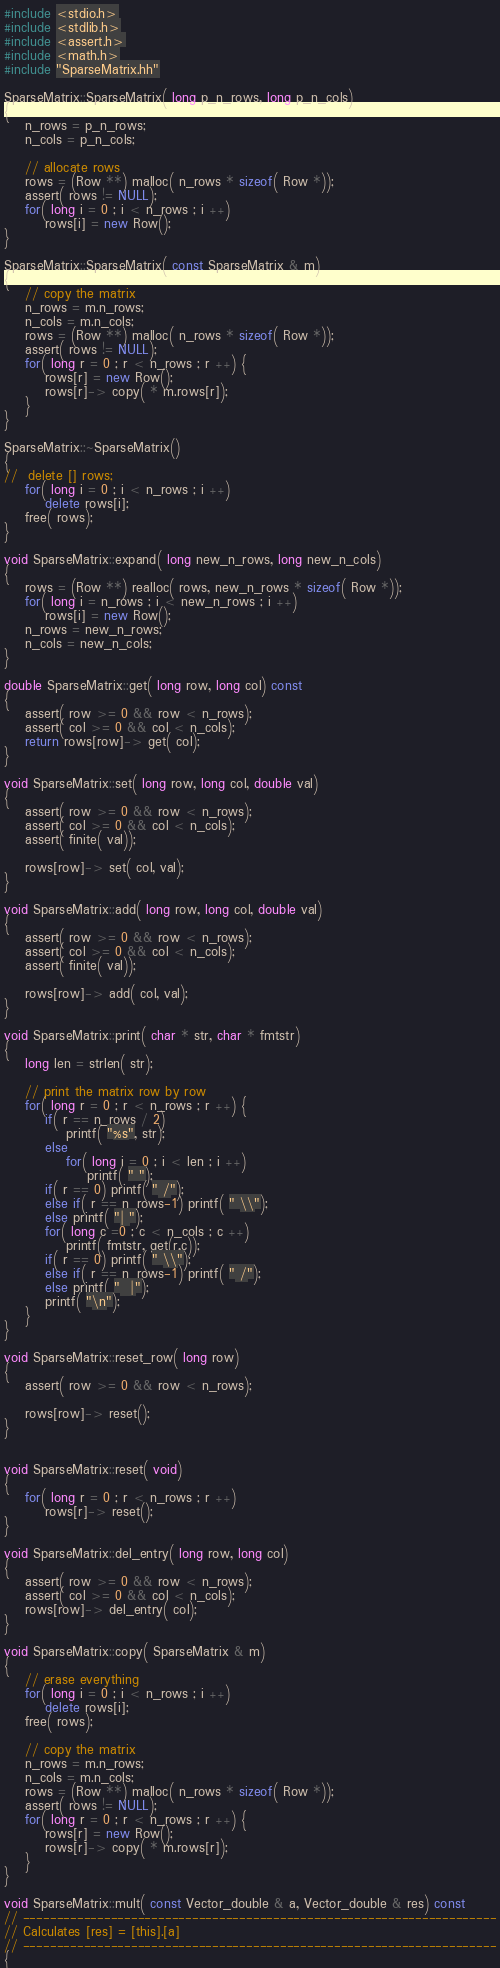Convert code to text. <code><loc_0><loc_0><loc_500><loc_500><_C++_>#include <stdio.h>
#include <stdlib.h>
#include <assert.h>
#include <math.h>
#include "SparseMatrix.hh"

SparseMatrix::SparseMatrix( long p_n_rows, long p_n_cols)
{
	n_rows = p_n_rows;
	n_cols = p_n_cols;

	// allocate rows
	rows = (Row **) malloc( n_rows * sizeof( Row *));
	assert( rows != NULL);
	for( long i = 0 ; i < n_rows ; i ++)
		rows[i] = new Row();
}

SparseMatrix::SparseMatrix( const SparseMatrix & m)
{
	// copy the matrix
	n_rows = m.n_rows;
	n_cols = m.n_cols;
	rows = (Row **) malloc( n_rows * sizeof( Row *));
	assert( rows != NULL);
	for( long r = 0 ; r < n_rows ; r ++) {
		rows[r] = new Row();
		rows[r]-> copy( * m.rows[r]);
	}
}

SparseMatrix::~SparseMatrix()
{
//	delete [] rows;
	for( long i = 0 ; i < n_rows ; i ++)
		delete rows[i];
	free( rows);
}

void SparseMatrix::expand( long new_n_rows, long new_n_cols)
{
	rows = (Row **) realloc( rows, new_n_rows * sizeof( Row *));
	for( long i = n_rows ; i < new_n_rows ; i ++)
		rows[i] = new Row();
	n_rows = new_n_rows;
	n_cols = new_n_cols;
}

double SparseMatrix::get( long row, long col) const 
{
	assert( row >= 0 && row < n_rows);
	assert( col >= 0 && col < n_cols);
	return rows[row]-> get( col);
}

void SparseMatrix::set( long row, long col, double val)
{
	assert( row >= 0 && row < n_rows);
	assert( col >= 0 && col < n_cols);
	assert( finite( val));

	rows[row]-> set( col, val);
}

void SparseMatrix::add( long row, long col, double val)
{
	assert( row >= 0 && row < n_rows);
	assert( col >= 0 && col < n_cols);
	assert( finite( val));

	rows[row]-> add( col, val);
}

void SparseMatrix::print( char * str, char * fmtstr)
{
	long len = strlen( str);

	// print the matrix row by row
	for( long r = 0 ; r < n_rows ; r ++) {
		if( r == n_rows / 2)
			printf( "%s", str);
		else
			for( long i = 0 ; i < len ; i ++)
				printf( " ");
		if( r == 0) printf( " /");
		else if( r == n_rows-1) printf( " \\");
		else printf( "| ");
		for( long c =0 ; c < n_cols ; c ++)
			printf( fmtstr, get(r,c));
		if( r == 0) printf( " \\");
		else if( r == n_rows-1) printf( " /");
		else printf( "  |");
		printf( "\n");
	}
}

void SparseMatrix::reset_row( long row)
{
	assert( row >= 0 && row < n_rows);

	rows[row]-> reset();
}


void SparseMatrix::reset( void)
{
	for( long r = 0 ; r < n_rows ; r ++)
		rows[r]-> reset();
}

void SparseMatrix::del_entry( long row, long col)
{
	assert( row >= 0 && row < n_rows);
	assert( col >= 0 && col < n_cols);
	rows[row]-> del_entry( col);
}

void SparseMatrix::copy( SparseMatrix & m)
{
	// erase everything
	for( long i = 0 ; i < n_rows ; i ++)
		delete rows[i];
	free( rows);

	// copy the matrix
	n_rows = m.n_rows;
	n_cols = m.n_cols;
	rows = (Row **) malloc( n_rows * sizeof( Row *));
	assert( rows != NULL);
	for( long r = 0 ; r < n_rows ; r ++) {
		rows[r] = new Row();
		rows[r]-> copy( * m.rows[r]);
	}
}

void SparseMatrix::mult( const Vector_double & a, Vector_double & res) const
// ----------------------------------------------------------------------
// Calculates [res] = [this].[a]
// ----------------------------------------------------------------------
{</code> 